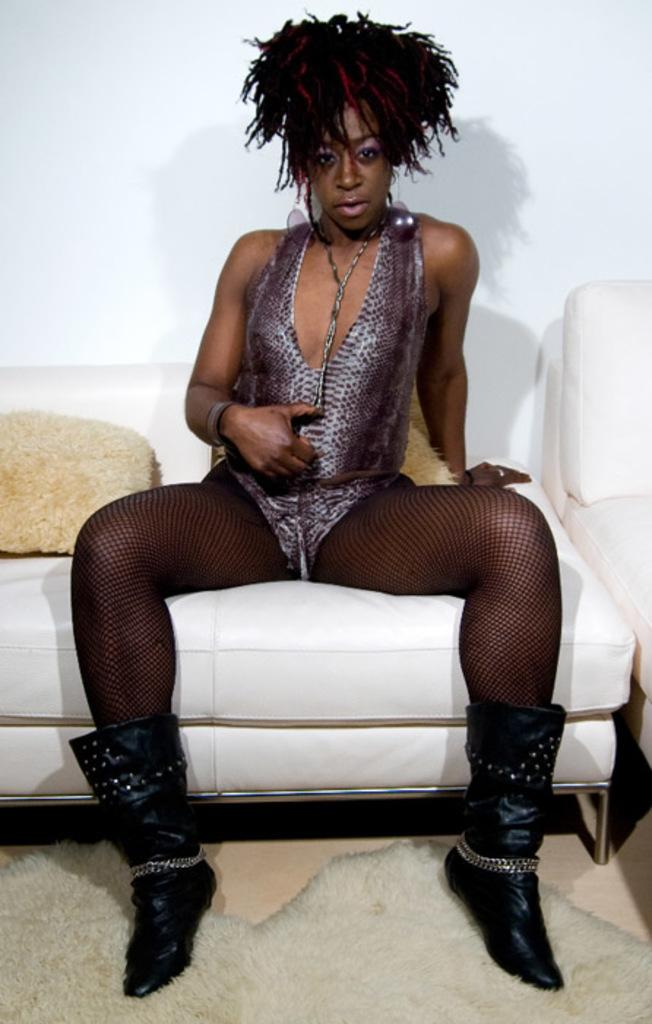Who is present in the image? There is a woman in the image. What is the woman wearing? The woman is wearing a dress. What is the woman doing in the image? The woman is sitting on a chair. What industry is the woman working in, as depicted in the image? The image does not provide any information about the woman's industry or occupation. 